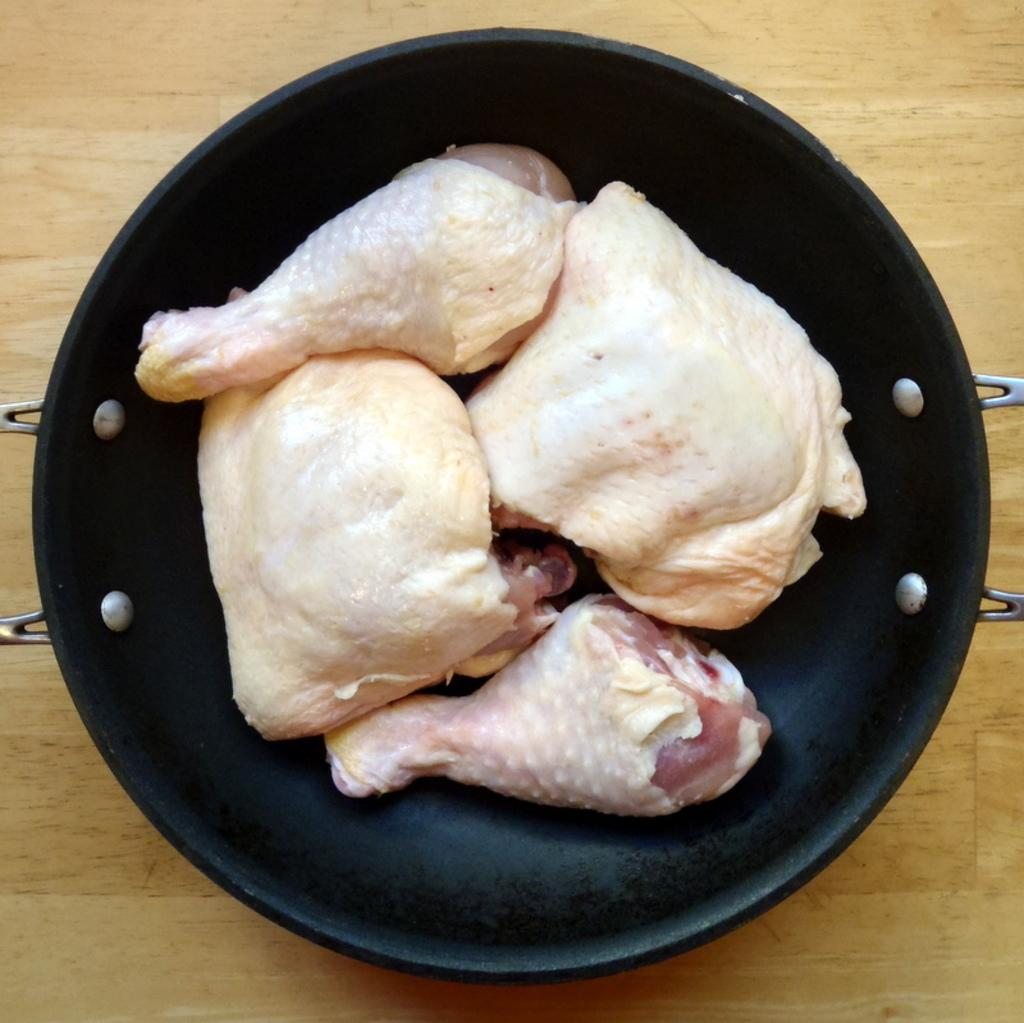What type of food is in the vessel in the image? There are chicken pieces in a vessel in the image. What piece of furniture is at the bottom of the image? There is a table at the bottom of the image. What type of haircut is the squirrel getting in the image? There is no squirrel present in the image, and therefore no haircut can be observed. 